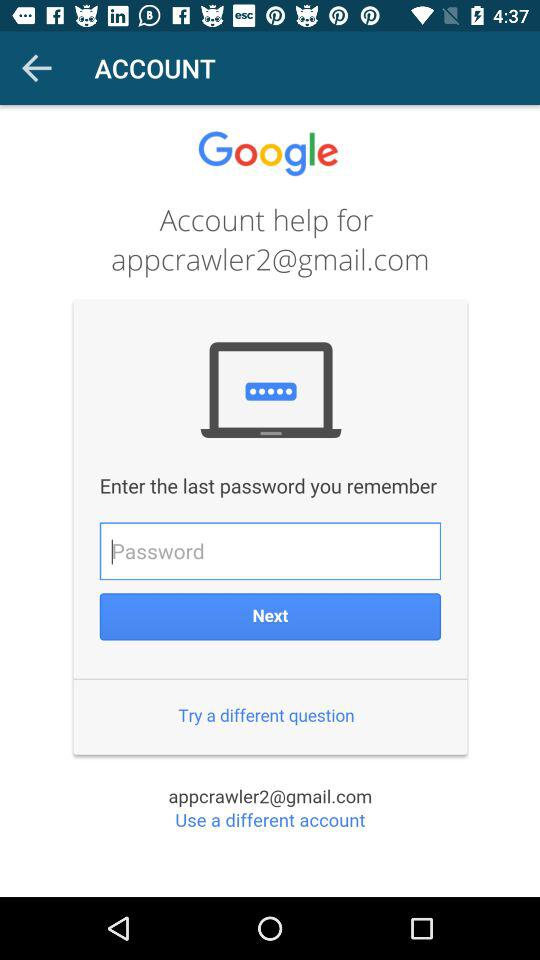What is the email address? The email address is appcrawler2@gmail.com. 